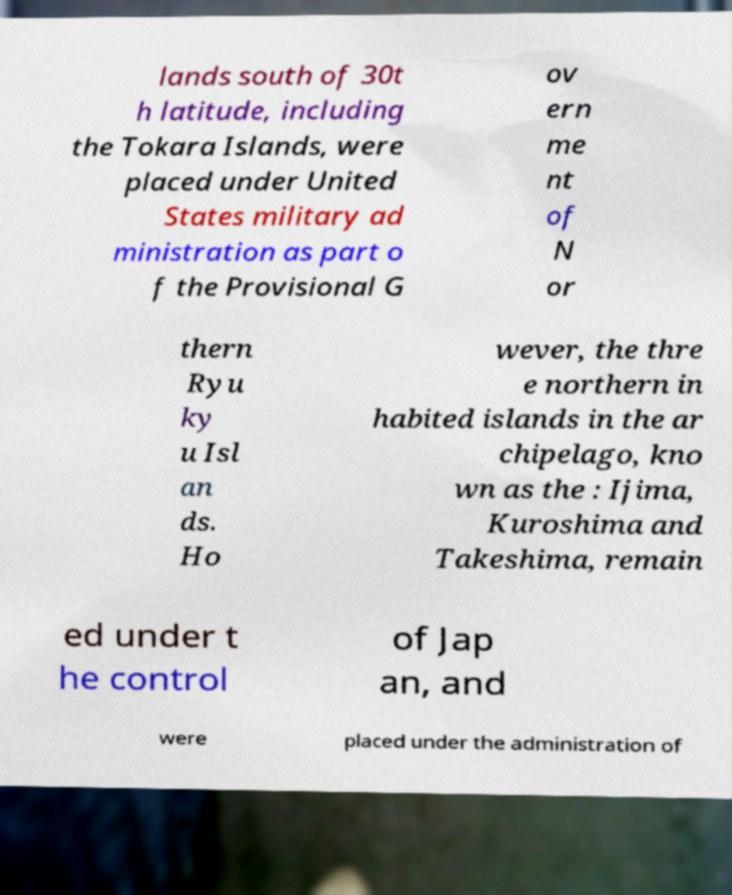There's text embedded in this image that I need extracted. Can you transcribe it verbatim? lands south of 30t h latitude, including the Tokara Islands, were placed under United States military ad ministration as part o f the Provisional G ov ern me nt of N or thern Ryu ky u Isl an ds. Ho wever, the thre e northern in habited islands in the ar chipelago, kno wn as the : Ijima, Kuroshima and Takeshima, remain ed under t he control of Jap an, and were placed under the administration of 